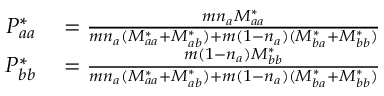Convert formula to latex. <formula><loc_0><loc_0><loc_500><loc_500>\begin{array} { r l } { P _ { a a } ^ { * } } & = \frac { m n _ { a } M _ { a a } ^ { * } } { m n _ { a } ( M _ { a a } ^ { * } + M _ { a b } ^ { * } ) + m ( 1 - n _ { a } ) ( M _ { b a } ^ { * } + M _ { b b } ^ { * } ) } } \\ { P _ { b b } ^ { * } } & = \frac { m ( 1 - n _ { a } ) M _ { b b } ^ { * } } { m n _ { a } ( M _ { a a } ^ { * } + M _ { a b } ^ { * } ) + m ( 1 - n _ { a } ) ( M _ { b a } ^ { * } + M _ { b b } ^ { * } ) } } \end{array}</formula> 